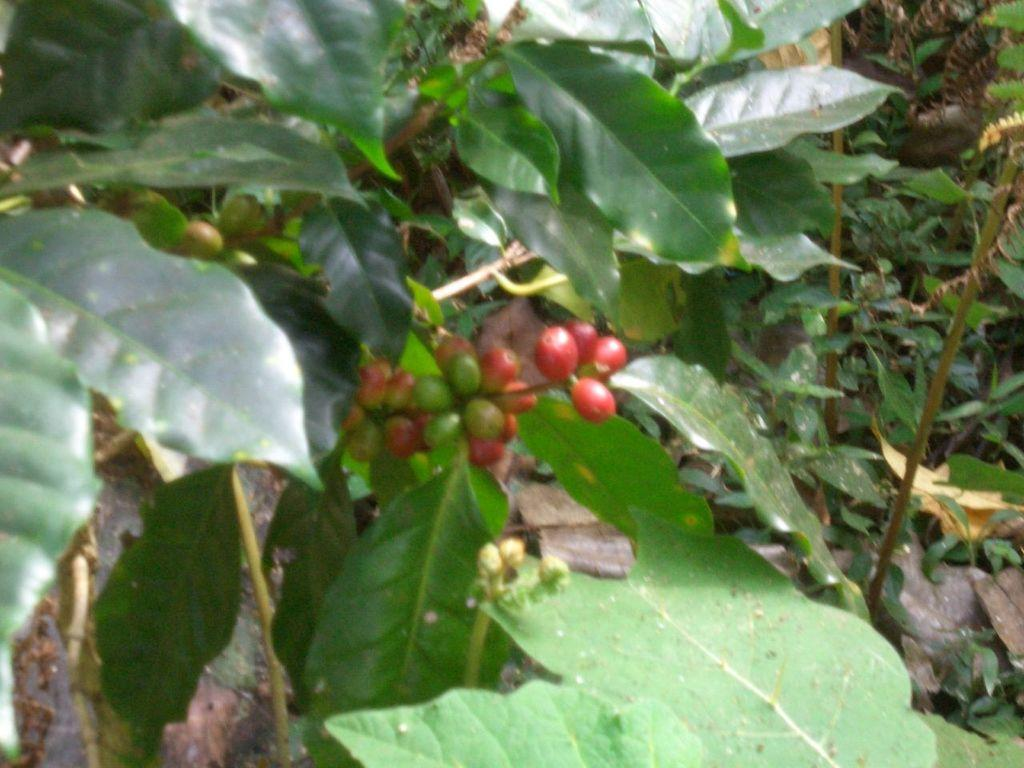What type of plant can be seen on the left side of the image? There is a plant with fruits and green leaves on the left side of the image. What can be seen on the right side of the image? There are green leaves of another plant on the right side of the image. Can you describe the plants visible in the background of the image? There are other plants visible in the background of the image. What type of picture is hanging on the wall in the image? There is no picture hanging on the wall in the image; it only features plants. Can you tell me how many celery stalks are visible in the image? There is no celery present in the image; it only features plants with fruits and green leaves. 